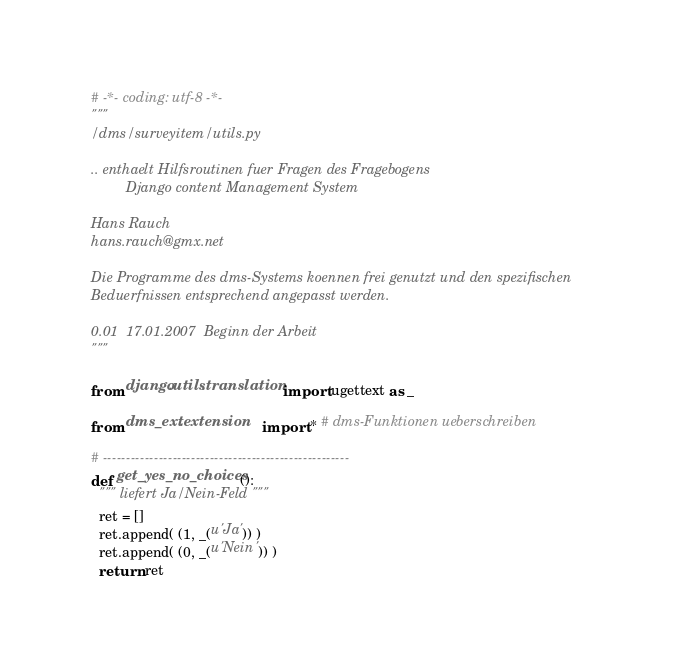Convert code to text. <code><loc_0><loc_0><loc_500><loc_500><_Python_># -*- coding: utf-8 -*-
"""
/dms/surveyitem/utils.py

.. enthaelt Hilfsroutinen fuer Fragen des Fragebogens
         Django content Management System

Hans Rauch
hans.rauch@gmx.net

Die Programme des dms-Systems koennen frei genutzt und den spezifischen
Beduerfnissen entsprechend angepasst werden.

0.01  17.01.2007  Beginn der Arbeit
"""

from django.utils.translation import ugettext as _

from dms_ext.extension    import * # dms-Funktionen ueberschreiben

# -----------------------------------------------------
def get_yes_no_choices():
  """ liefert Ja/Nein-Feld """
  ret = []
  ret.append( (1, _(u'Ja')) )
  ret.append( (0, _(u'Nein')) )
  return ret

</code> 